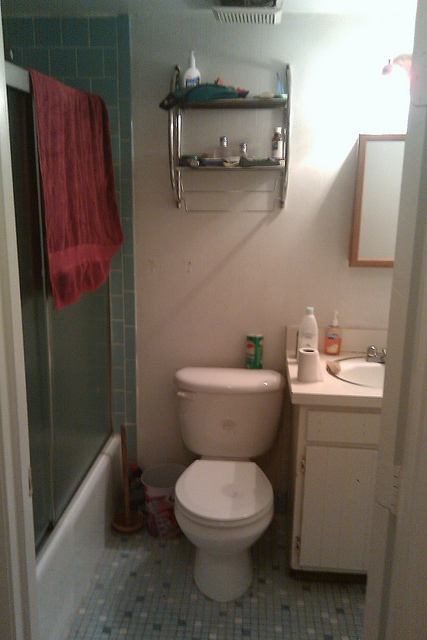What color scheme is the bathroom? The bathroom features a simple color scheme, dominated by white hues, from the toilet and sink to the tiled walls. There's also a contrasting dark blue shower curtain and a red towel hanging, adding a touch of color to the space.  Are there any personal care products visible other than the one on the toilet tank? Yes, aside from the container on the toilet tank, there's a bottle that likely contains a body wash or shampoo on the edge of the bathtub, and a hand soap dispenser next to the sink. 